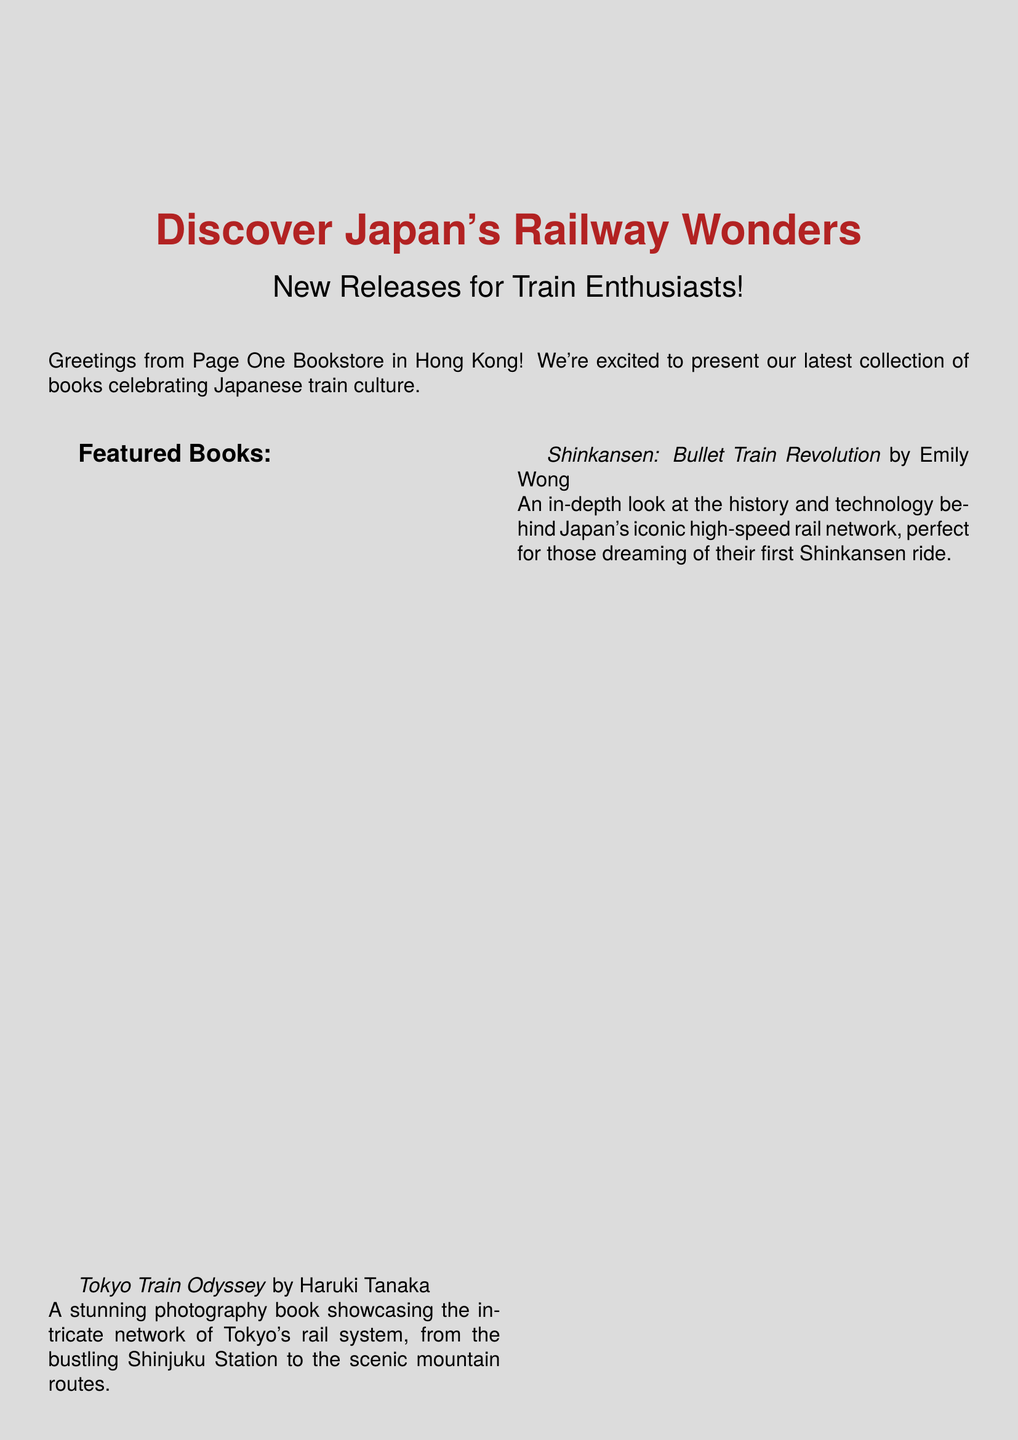What is the subject of the email? The subject is highlighted at the top of the document and states the main theme of the email.
Answer: Discover Japan's Railway Wonders: New Releases for Train Enthusiasts! Who is the author of "Tokyo Train Odyssey"? The email mentions the author of this book under its title in the featured books section.
Answer: Haruki Tanaka What discount code is provided in the email? The email includes a special offer with a discount code in the promotional section.
Answer: TOKYOEXPRESS Name one manga title recommended in the email. The email lists several titles in the manga section, showcasing suggested reading.
Answer: Galaxy Express 999 How many featured books are there in total? The document lists the featured books and can be counted directly to provide the total number.
Answer: Three What type of book is "Shinkansen: Bullet Train Revolution"? The description specifies the category of this book, which relates to its content focus.
Answer: In-depth look What cultural aspect does the email invite readers to immerse themselves in? The email focuses on the specific cultural elements related to the subject of the books featured.
Answer: Japanese rail culture What is the emphasis of the "Train-Themed Manga Corner"? The email provides a description that sets the thematic focus of this section.
Answer: Captivating manga series 